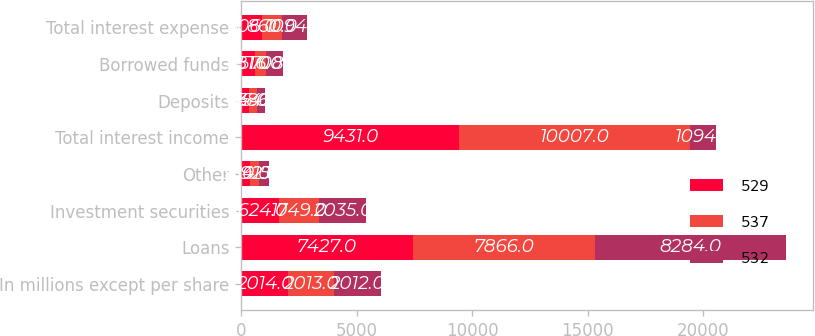Convert chart to OTSL. <chart><loc_0><loc_0><loc_500><loc_500><stacked_bar_chart><ecel><fcel>In millions except per share<fcel>Loans<fcel>Investment securities<fcel>Other<fcel>Total interest income<fcel>Deposits<fcel>Borrowed funds<fcel>Total interest expense<nl><fcel>529<fcel>2014<fcel>7427<fcel>1624<fcel>380<fcel>9431<fcel>325<fcel>581<fcel>906<nl><fcel>537<fcel>2013<fcel>7866<fcel>1749<fcel>392<fcel>10007<fcel>344<fcel>516<fcel>860<nl><fcel>532<fcel>2012<fcel>8284<fcel>2035<fcel>415<fcel>1094<fcel>386<fcel>708<fcel>1094<nl></chart> 